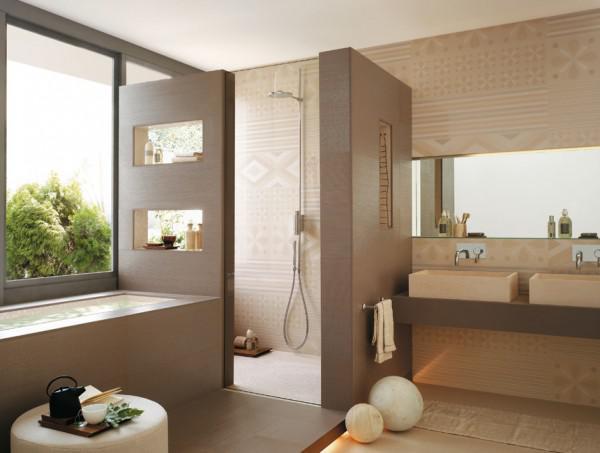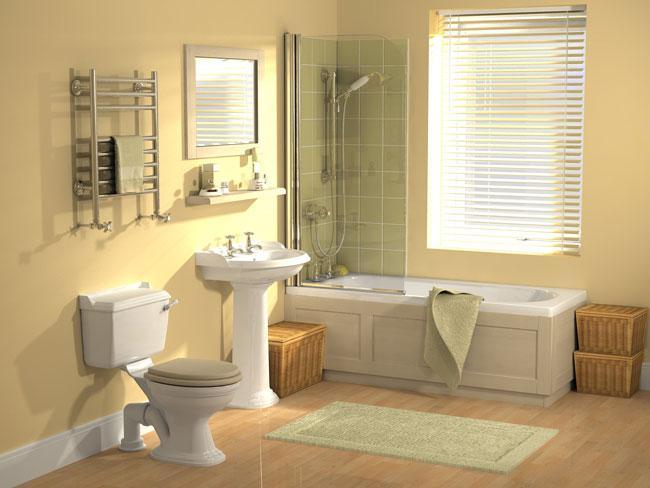The first image is the image on the left, the second image is the image on the right. Examine the images to the left and right. Is the description "There are at least 3 toilets next to showers." accurate? Answer yes or no. No. 